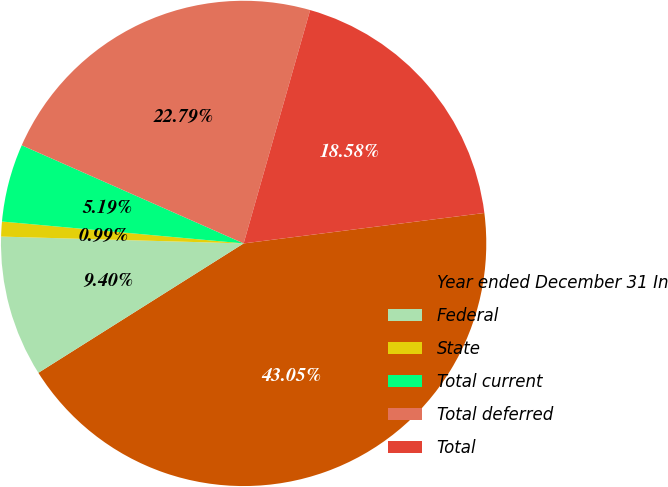Convert chart to OTSL. <chart><loc_0><loc_0><loc_500><loc_500><pie_chart><fcel>Year ended December 31 In<fcel>Federal<fcel>State<fcel>Total current<fcel>Total deferred<fcel>Total<nl><fcel>43.05%<fcel>9.4%<fcel>0.99%<fcel>5.19%<fcel>22.79%<fcel>18.58%<nl></chart> 